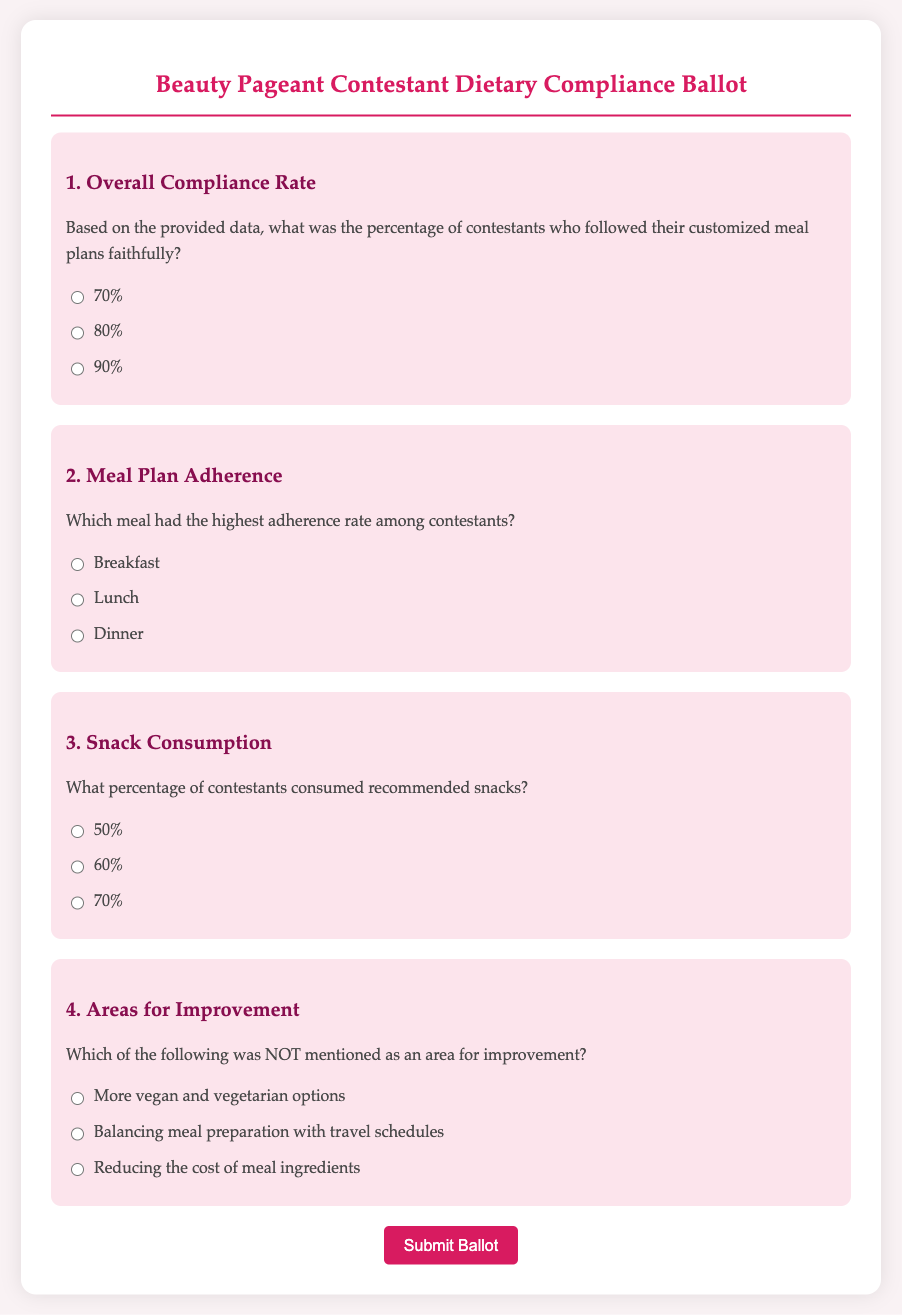What was the overall compliance percentage? The question asks for the specific percent of contestants who followed their customized meal plans, which is presented in the options in the document.
Answer: 70% Which meal had the highest adherence rate? The document explicitly states the meals in options, and we must choose the one with the highest adherence based on the provided context.
Answer: Breakfast What percentage of contestants consumed recommended snacks? The document lists multiple choices for this percentage, asking the voter to select an answer based on the information presented.
Answer: 60% Which area for improvement was NOT mentioned? The question requires referencing options given in the ballot, asking for the one that is not included as an area needing improvement based on contestant feedback.
Answer: Reducing the cost of meal ingredients What is the background color of the document? The question is about a visual aspect of the document's design, asking for a specific color reference.
Answer: #f9f2f4 